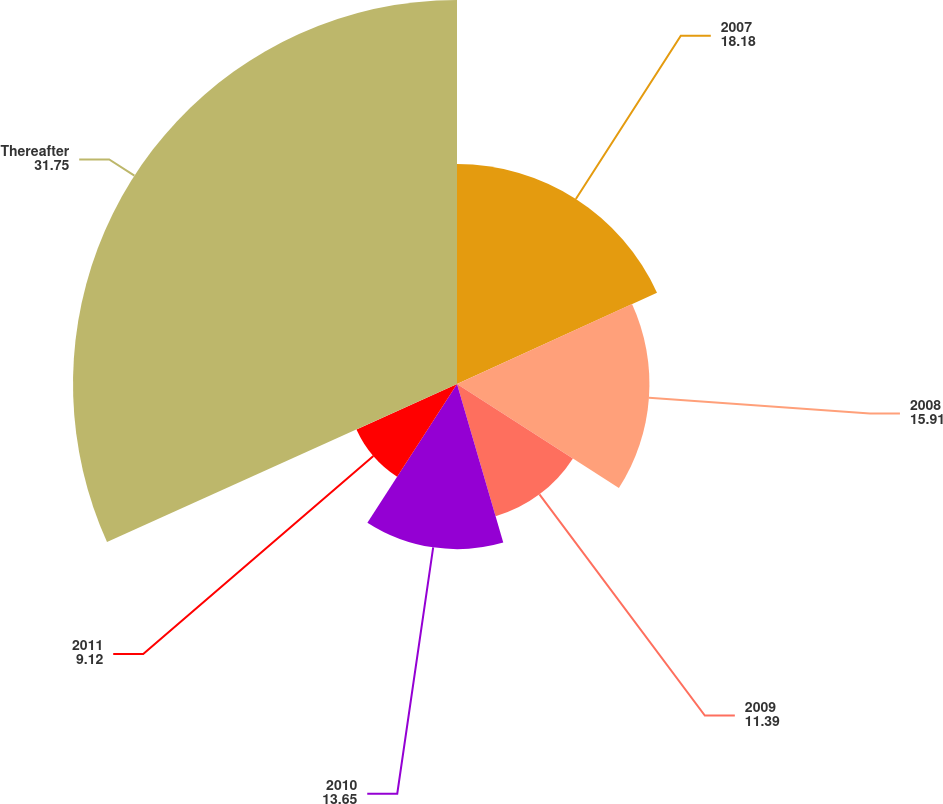<chart> <loc_0><loc_0><loc_500><loc_500><pie_chart><fcel>2007<fcel>2008<fcel>2009<fcel>2010<fcel>2011<fcel>Thereafter<nl><fcel>18.18%<fcel>15.91%<fcel>11.39%<fcel>13.65%<fcel>9.12%<fcel>31.75%<nl></chart> 